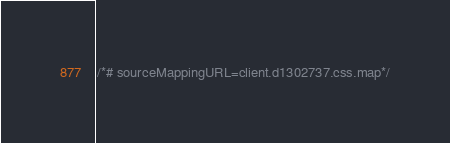<code> <loc_0><loc_0><loc_500><loc_500><_CSS_>/*# sourceMappingURL=client.d1302737.css.map*/</code> 